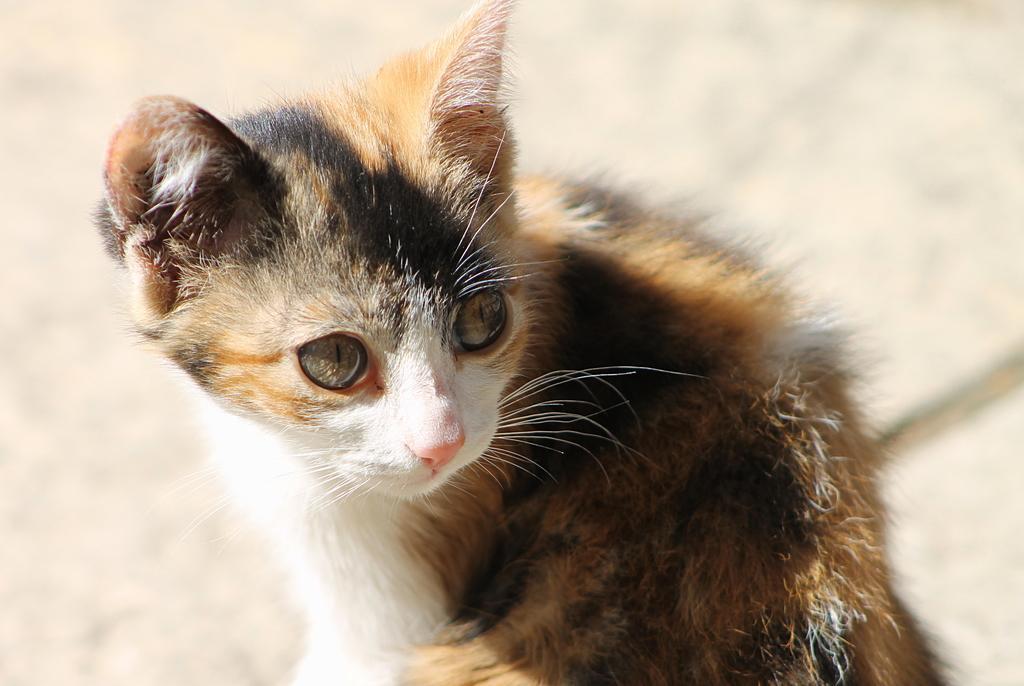In one or two sentences, can you explain what this image depicts? In this image we can see a cat on the surface. 